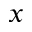Convert formula to latex. <formula><loc_0><loc_0><loc_500><loc_500>x</formula> 